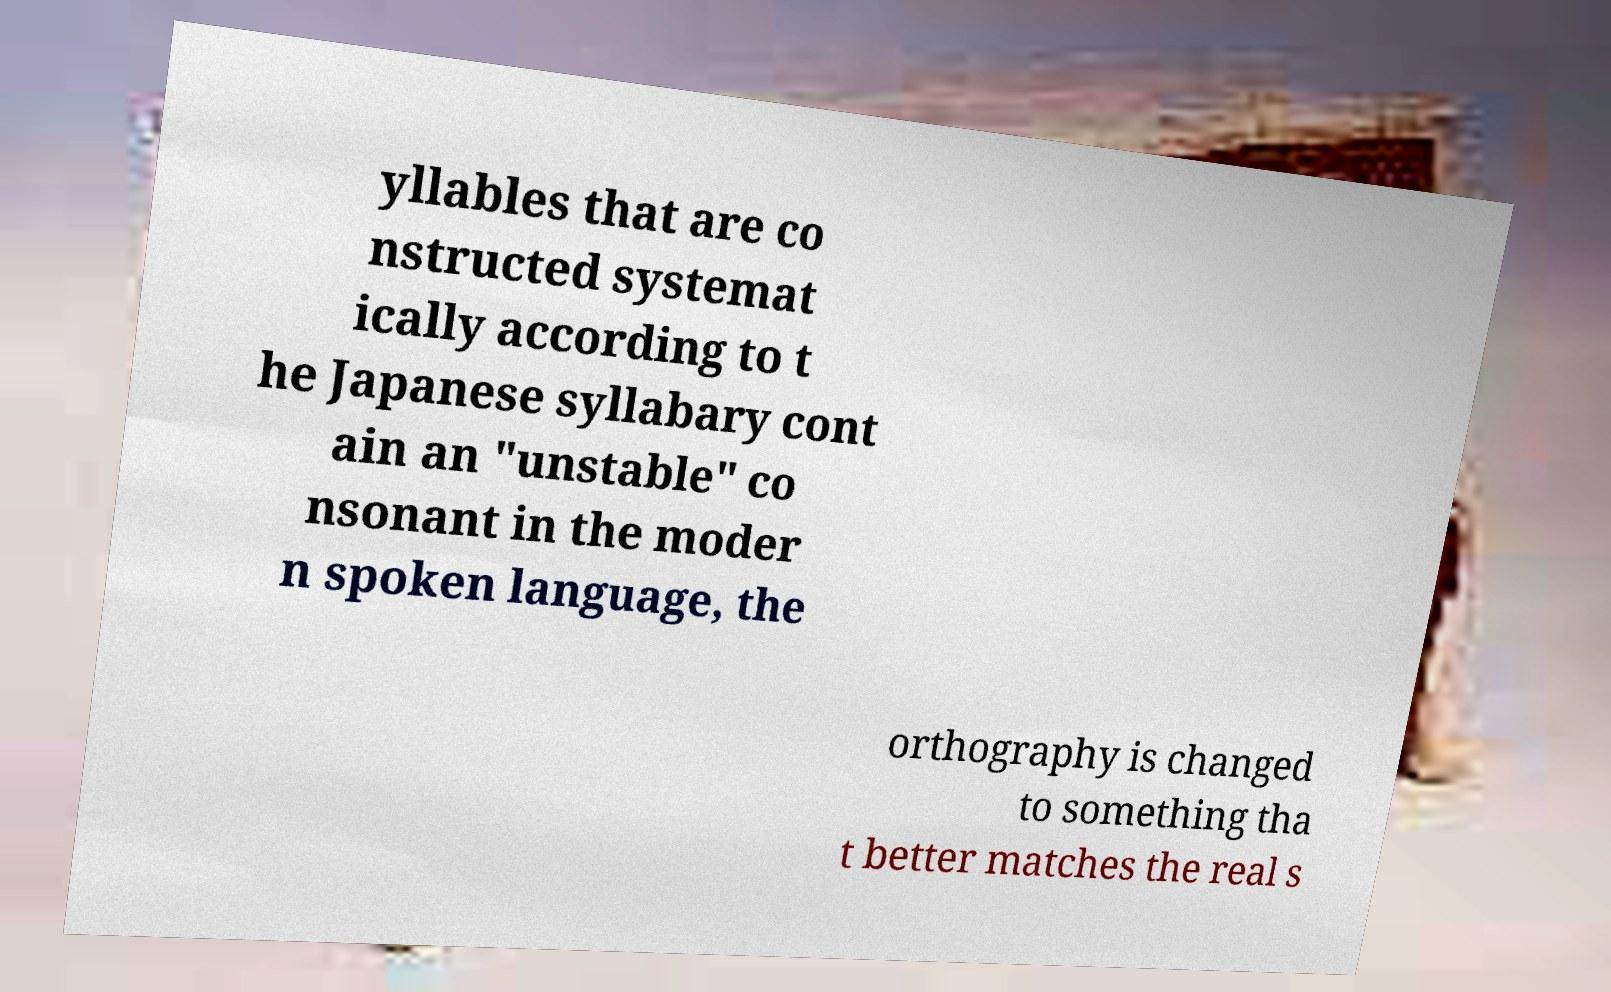For documentation purposes, I need the text within this image transcribed. Could you provide that? yllables that are co nstructed systemat ically according to t he Japanese syllabary cont ain an "unstable" co nsonant in the moder n spoken language, the orthography is changed to something tha t better matches the real s 